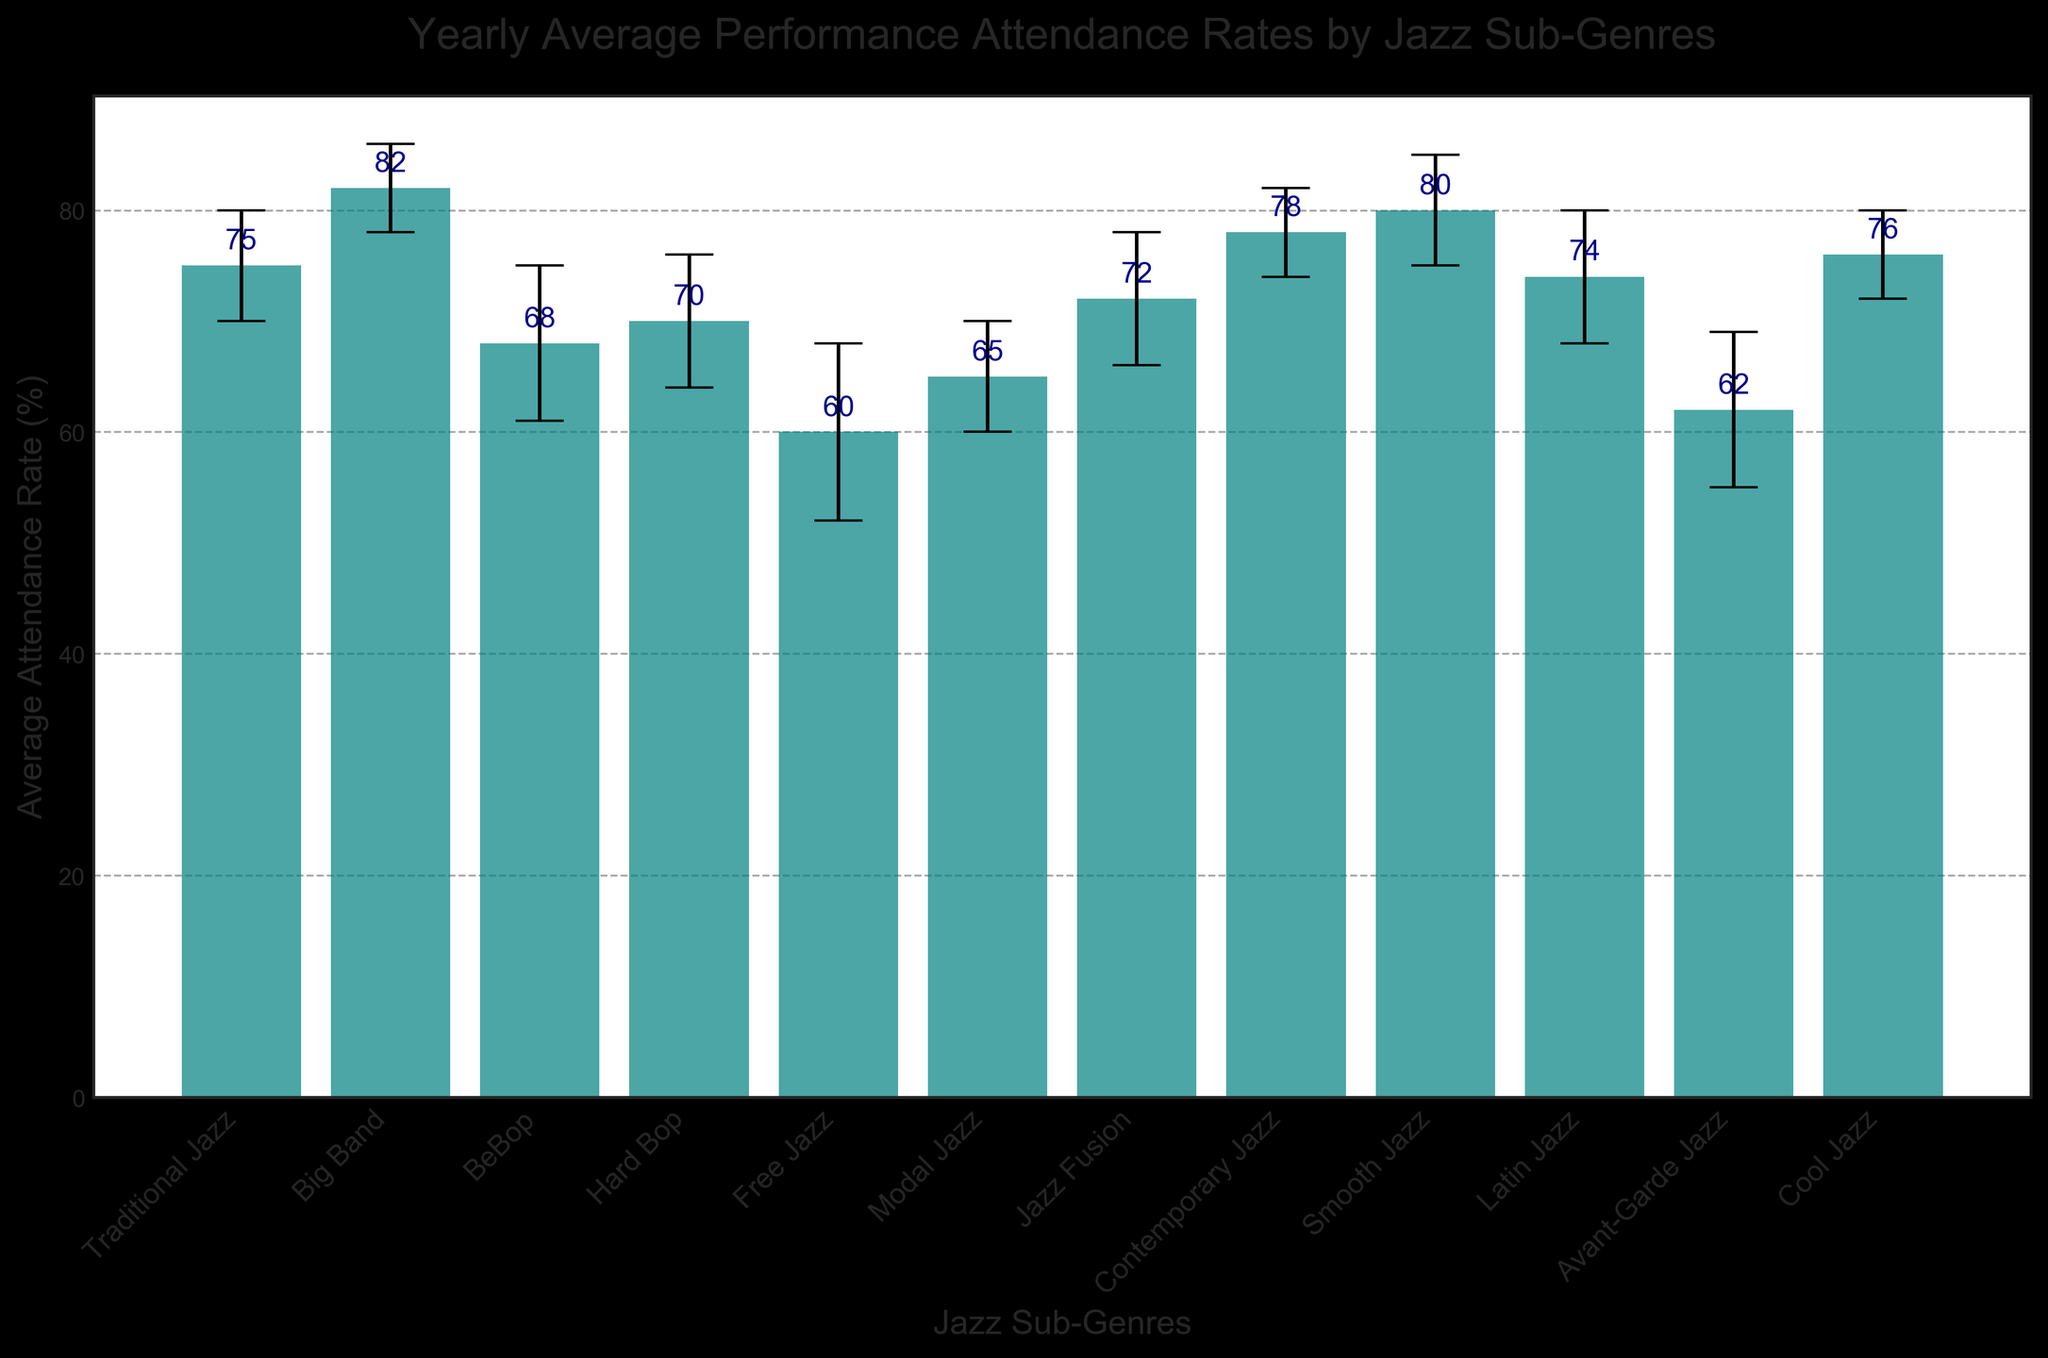What is the average attendance rate for Smooth Jazz? Locate the bar for Smooth Jazz, then check the height of the bar and the text label above it, which shows the average attendance rate.
Answer: 80 Which Jazz sub-genre has the highest average attendance rate? Compare the heights of all the bars in the chart and identify the one with the greatest height and corresponding value.
Answer: Big Band How does the average attendance rate for Free Jazz compare to Avant-Garde Jazz? Find the bars for Free Jazz and Avant-Garde Jazz, compare their heights or their value labels. Free Jazz has 60% while Avant-Garde Jazz has 62%.
Answer: Avant-Garde Jazz is higher by 2 points What is the difference in attendance rates between Big Band and Traditional Jazz? Locate the respective bars for Big Band (82%) and Traditional Jazz (75%). Subtract the smaller value from the larger value. 82 - 75 = 7
Answer: 7 Which sub-genre has the largest standard deviation in attendance rates? Look at the error bars (caps) for all the sub-genres and find the one with the largest range. Free Jazz has the largest standard deviation of 8%.
Answer: Free Jazz What is the sum of the average attendance rates for Contemporary Jazz and Cool Jazz? Find the values for Contemporary Jazz (78%) and Cool Jazz (76%). Add these two values together: 78 + 76 = 154
Answer: 154 Based on the chart, what is the average attendance rate across all Jazz sub-genres? Sum up all the attendance rates given for each sub-genre and divide by the number of sub-genres (12). (75 + 82 + 68 + 70 + 60 + 65 + 72 + 78 + 80 + 74 + 62 + 76) / 12 = 75
Answer: 75 Between Modal Jazz and Latin Jazz, which has a higher average attendance rate and by how much? Compare the attendance rates for Modal Jazz (65%) and Latin Jazz (74%). Latin Jazz is higher. Subtract the smaller value from the larger one: 74 - 65 = 9
Answer: Latin Jazz by 9 points What is the range of average attendance rates across all sub-genres? Identify the highest and lowest attendance rates from the chart. The highest is Big Band (82%) and the lowest is Free Jazz (60%). Subtract the lowest from the highest: 82 - 60 = 22
Answer: 22 What is the standard deviation for Hard Bop? Locate the error bar for Hard Bop and identify its length, which represents the standard deviation. The standard deviation for Hard Bop is 6.
Answer: 6 